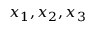Convert formula to latex. <formula><loc_0><loc_0><loc_500><loc_500>x _ { 1 } , x _ { 2 } , x _ { 3 }</formula> 